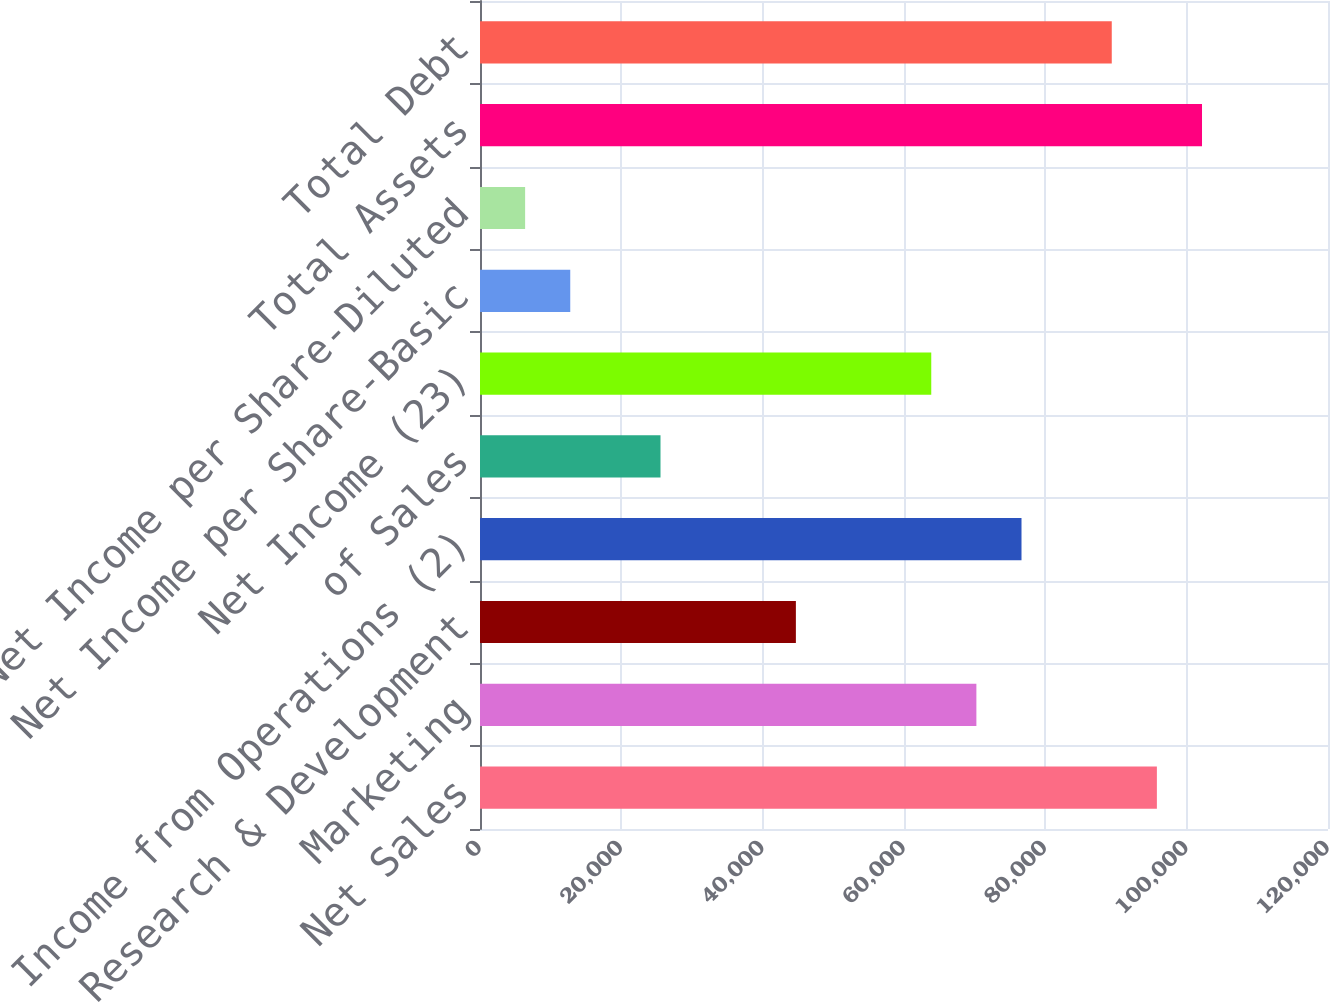Convert chart to OTSL. <chart><loc_0><loc_0><loc_500><loc_500><bar_chart><fcel>Net Sales<fcel>Marketing<fcel>Research & Development<fcel>Income from Operations (2)<fcel>of Sales<fcel>Net Income (23)<fcel>Net Income per Share-Basic<fcel>Net Income per Share-Diluted<fcel>Total Assets<fcel>Total Debt<nl><fcel>95785.4<fcel>70242.7<fcel>44700<fcel>76628.4<fcel>25543<fcel>63857<fcel>12771.6<fcel>6385.92<fcel>102171<fcel>89399.8<nl></chart> 